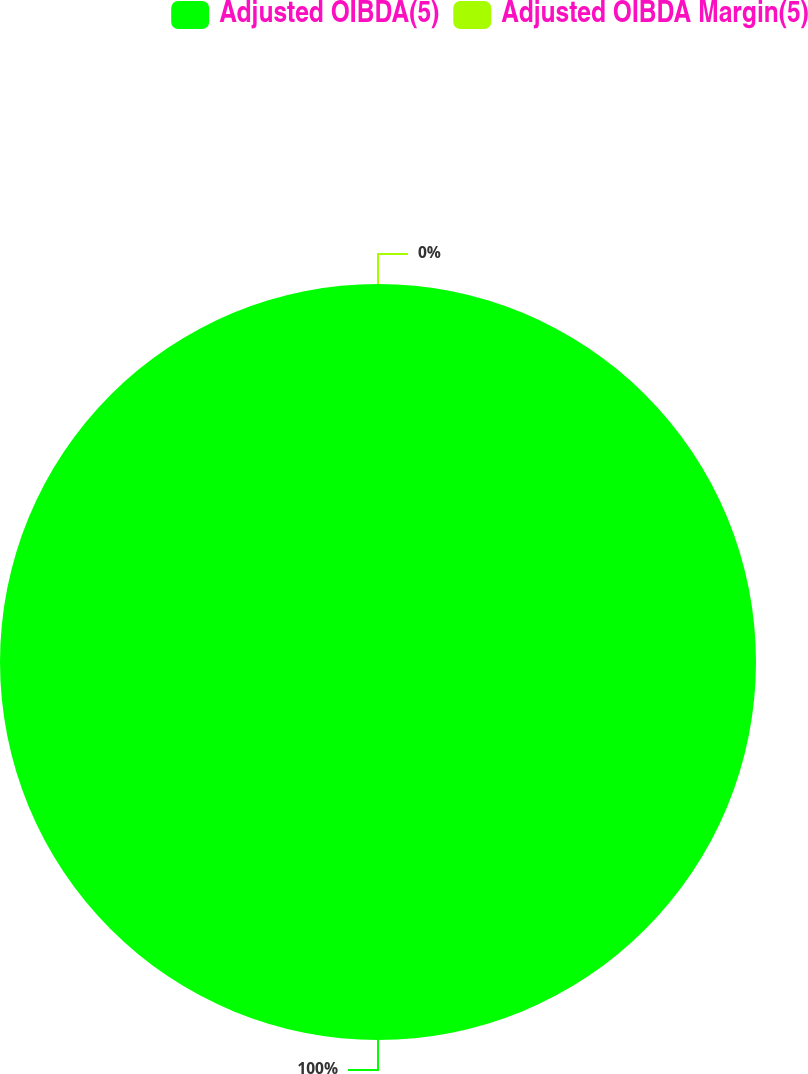Convert chart. <chart><loc_0><loc_0><loc_500><loc_500><pie_chart><fcel>Adjusted OIBDA(5)<fcel>Adjusted OIBDA Margin(5)<nl><fcel>100.0%<fcel>0.0%<nl></chart> 